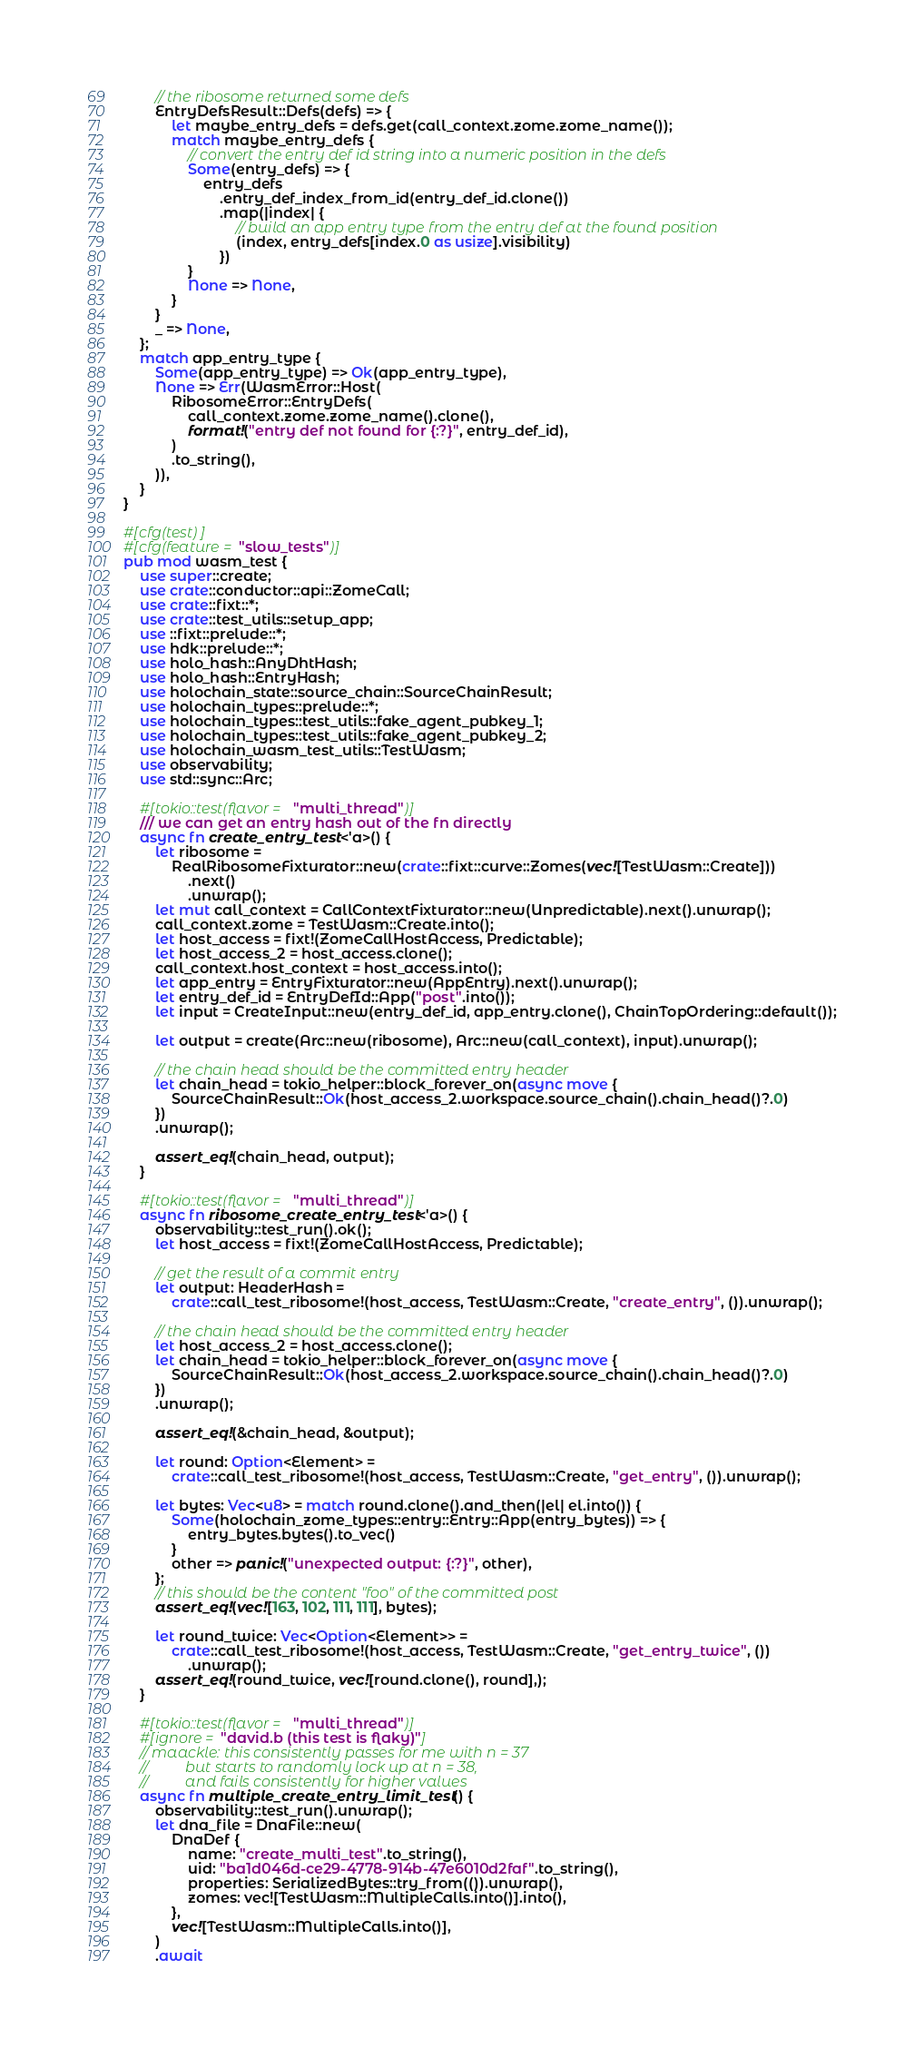Convert code to text. <code><loc_0><loc_0><loc_500><loc_500><_Rust_>        // the ribosome returned some defs
        EntryDefsResult::Defs(defs) => {
            let maybe_entry_defs = defs.get(call_context.zome.zome_name());
            match maybe_entry_defs {
                // convert the entry def id string into a numeric position in the defs
                Some(entry_defs) => {
                    entry_defs
                        .entry_def_index_from_id(entry_def_id.clone())
                        .map(|index| {
                            // build an app entry type from the entry def at the found position
                            (index, entry_defs[index.0 as usize].visibility)
                        })
                }
                None => None,
            }
        }
        _ => None,
    };
    match app_entry_type {
        Some(app_entry_type) => Ok(app_entry_type),
        None => Err(WasmError::Host(
            RibosomeError::EntryDefs(
                call_context.zome.zome_name().clone(),
                format!("entry def not found for {:?}", entry_def_id),
            )
            .to_string(),
        )),
    }
}

#[cfg(test)]
#[cfg(feature = "slow_tests")]
pub mod wasm_test {
    use super::create;
    use crate::conductor::api::ZomeCall;
    use crate::fixt::*;
    use crate::test_utils::setup_app;
    use ::fixt::prelude::*;
    use hdk::prelude::*;
    use holo_hash::AnyDhtHash;
    use holo_hash::EntryHash;
    use holochain_state::source_chain::SourceChainResult;
    use holochain_types::prelude::*;
    use holochain_types::test_utils::fake_agent_pubkey_1;
    use holochain_types::test_utils::fake_agent_pubkey_2;
    use holochain_wasm_test_utils::TestWasm;
    use observability;
    use std::sync::Arc;

    #[tokio::test(flavor = "multi_thread")]
    /// we can get an entry hash out of the fn directly
    async fn create_entry_test<'a>() {
        let ribosome =
            RealRibosomeFixturator::new(crate::fixt::curve::Zomes(vec![TestWasm::Create]))
                .next()
                .unwrap();
        let mut call_context = CallContextFixturator::new(Unpredictable).next().unwrap();
        call_context.zome = TestWasm::Create.into();
        let host_access = fixt!(ZomeCallHostAccess, Predictable);
        let host_access_2 = host_access.clone();
        call_context.host_context = host_access.into();
        let app_entry = EntryFixturator::new(AppEntry).next().unwrap();
        let entry_def_id = EntryDefId::App("post".into());
        let input = CreateInput::new(entry_def_id, app_entry.clone(), ChainTopOrdering::default());

        let output = create(Arc::new(ribosome), Arc::new(call_context), input).unwrap();

        // the chain head should be the committed entry header
        let chain_head = tokio_helper::block_forever_on(async move {
            SourceChainResult::Ok(host_access_2.workspace.source_chain().chain_head()?.0)
        })
        .unwrap();

        assert_eq!(chain_head, output);
    }

    #[tokio::test(flavor = "multi_thread")]
    async fn ribosome_create_entry_test<'a>() {
        observability::test_run().ok();
        let host_access = fixt!(ZomeCallHostAccess, Predictable);

        // get the result of a commit entry
        let output: HeaderHash =
            crate::call_test_ribosome!(host_access, TestWasm::Create, "create_entry", ()).unwrap();

        // the chain head should be the committed entry header
        let host_access_2 = host_access.clone();
        let chain_head = tokio_helper::block_forever_on(async move {
            SourceChainResult::Ok(host_access_2.workspace.source_chain().chain_head()?.0)
        })
        .unwrap();

        assert_eq!(&chain_head, &output);

        let round: Option<Element> =
            crate::call_test_ribosome!(host_access, TestWasm::Create, "get_entry", ()).unwrap();

        let bytes: Vec<u8> = match round.clone().and_then(|el| el.into()) {
            Some(holochain_zome_types::entry::Entry::App(entry_bytes)) => {
                entry_bytes.bytes().to_vec()
            }
            other => panic!("unexpected output: {:?}", other),
        };
        // this should be the content "foo" of the committed post
        assert_eq!(vec![163, 102, 111, 111], bytes);

        let round_twice: Vec<Option<Element>> =
            crate::call_test_ribosome!(host_access, TestWasm::Create, "get_entry_twice", ())
                .unwrap();
        assert_eq!(round_twice, vec![round.clone(), round],);
    }

    #[tokio::test(flavor = "multi_thread")]
    #[ignore = "david.b (this test is flaky)"]
    // maackle: this consistently passes for me with n = 37
    //          but starts to randomly lock up at n = 38,
    //          and fails consistently for higher values
    async fn multiple_create_entry_limit_test() {
        observability::test_run().unwrap();
        let dna_file = DnaFile::new(
            DnaDef {
                name: "create_multi_test".to_string(),
                uid: "ba1d046d-ce29-4778-914b-47e6010d2faf".to_string(),
                properties: SerializedBytes::try_from(()).unwrap(),
                zomes: vec![TestWasm::MultipleCalls.into()].into(),
            },
            vec![TestWasm::MultipleCalls.into()],
        )
        .await</code> 